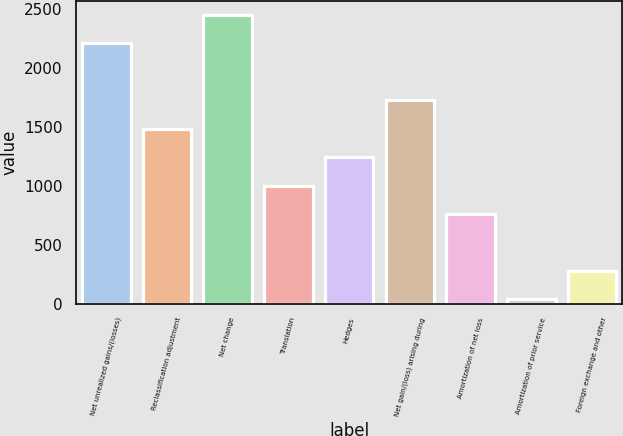Convert chart to OTSL. <chart><loc_0><loc_0><loc_500><loc_500><bar_chart><fcel>Net unrealized gains/(losses)<fcel>Reclassification adjustment<fcel>Net change<fcel>Translation<fcel>Hedges<fcel>Net gain/(loss) arising during<fcel>Amortization of net loss<fcel>Amortization of prior service<fcel>Foreign exchange and other<nl><fcel>2209.5<fcel>1485<fcel>2451<fcel>1002<fcel>1243.5<fcel>1726.5<fcel>760.5<fcel>36<fcel>277.5<nl></chart> 